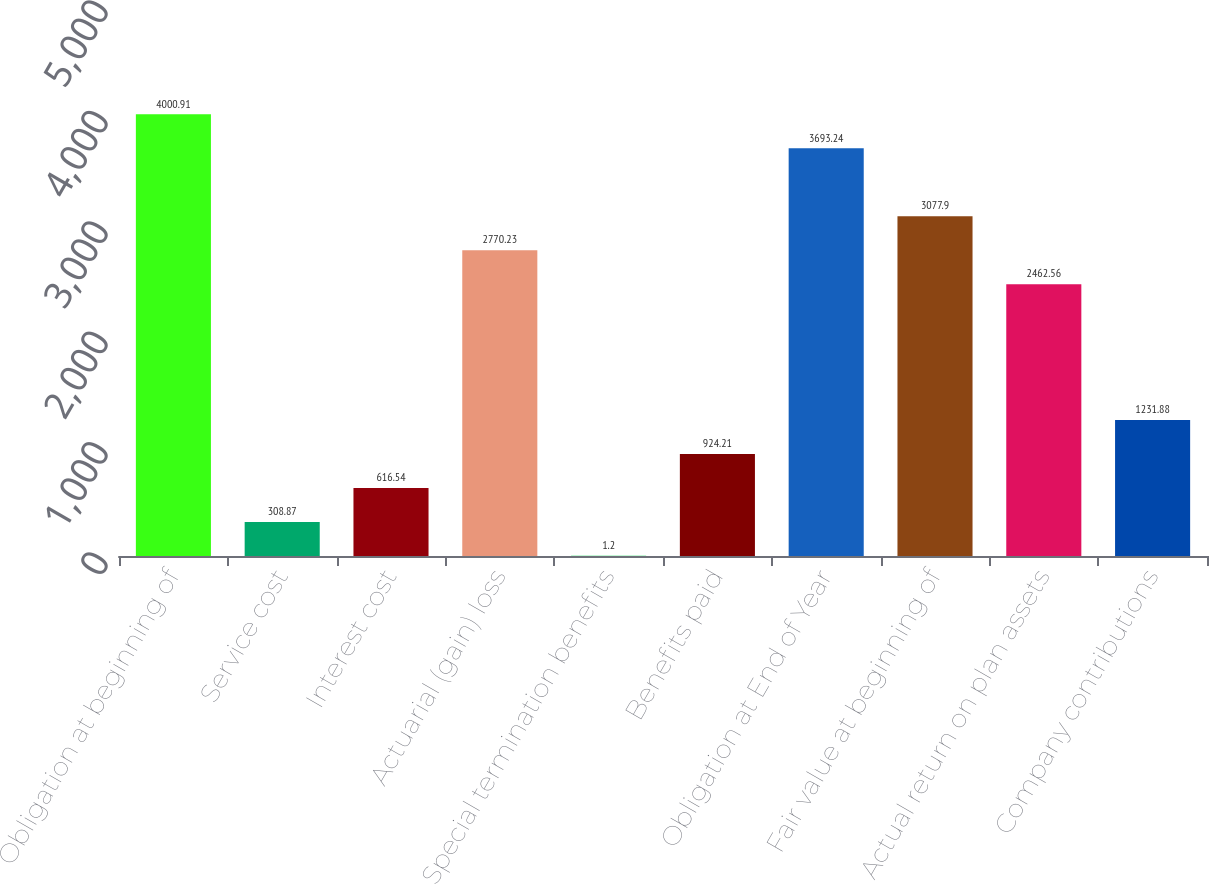Convert chart to OTSL. <chart><loc_0><loc_0><loc_500><loc_500><bar_chart><fcel>Obligation at beginning of<fcel>Service cost<fcel>Interest cost<fcel>Actuarial (gain) loss<fcel>Special termination benefits<fcel>Benefits paid<fcel>Obligation at End of Year<fcel>Fair value at beginning of<fcel>Actual return on plan assets<fcel>Company contributions<nl><fcel>4000.91<fcel>308.87<fcel>616.54<fcel>2770.23<fcel>1.2<fcel>924.21<fcel>3693.24<fcel>3077.9<fcel>2462.56<fcel>1231.88<nl></chart> 